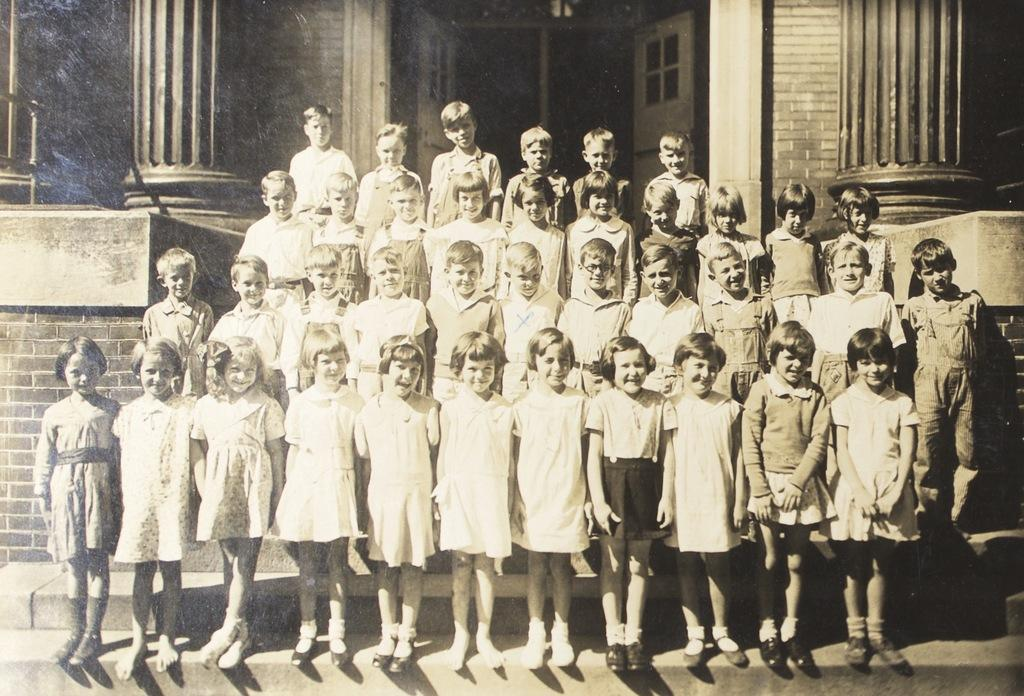What is the color scheme of the image? The image is black and white. Who or what can be seen in the image? There are children in the image. Where are the children located in the image? The children are standing on the steps of a building. What type of science experiment can be seen taking place at the seashore in the image? There is no seashore or science experiment present in the image; it features children standing on the steps of a building. 